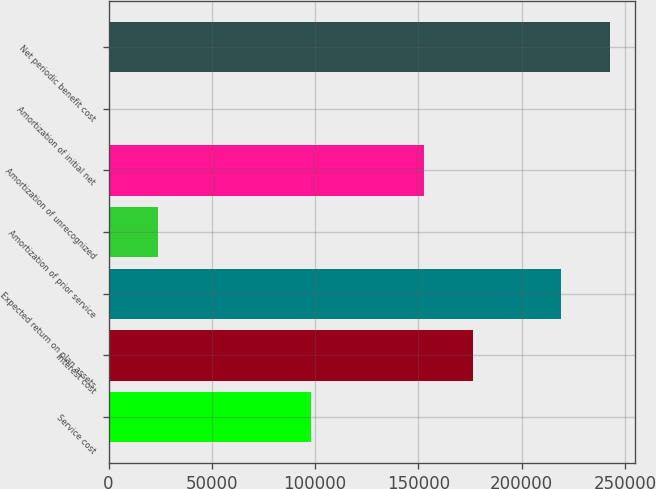<chart> <loc_0><loc_0><loc_500><loc_500><bar_chart><fcel>Service cost<fcel>Interest cost<fcel>Expected return on plan assets<fcel>Amortization of prior service<fcel>Amortization of unrecognized<fcel>Amortization of initial net<fcel>Net periodic benefit cost<nl><fcel>97960<fcel>176556<fcel>218938<fcel>23902.3<fcel>152664<fcel>17<fcel>242823<nl></chart> 